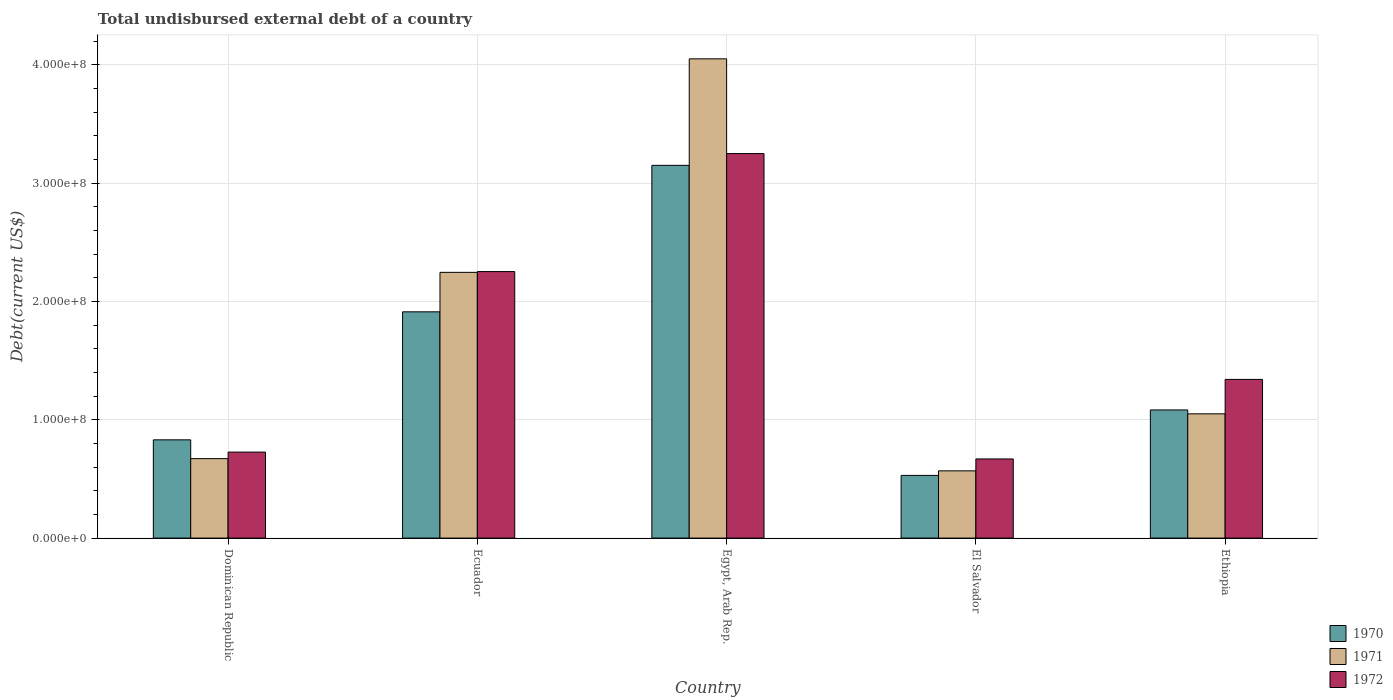How many groups of bars are there?
Give a very brief answer. 5. Are the number of bars per tick equal to the number of legend labels?
Provide a succinct answer. Yes. How many bars are there on the 4th tick from the right?
Keep it short and to the point. 3. What is the label of the 4th group of bars from the left?
Ensure brevity in your answer.  El Salvador. In how many cases, is the number of bars for a given country not equal to the number of legend labels?
Offer a terse response. 0. What is the total undisbursed external debt in 1971 in Ethiopia?
Your response must be concise. 1.05e+08. Across all countries, what is the maximum total undisbursed external debt in 1971?
Provide a short and direct response. 4.05e+08. Across all countries, what is the minimum total undisbursed external debt in 1972?
Your response must be concise. 6.69e+07. In which country was the total undisbursed external debt in 1971 maximum?
Provide a succinct answer. Egypt, Arab Rep. In which country was the total undisbursed external debt in 1972 minimum?
Your answer should be very brief. El Salvador. What is the total total undisbursed external debt in 1972 in the graph?
Ensure brevity in your answer.  8.24e+08. What is the difference between the total undisbursed external debt in 1971 in Dominican Republic and that in Ethiopia?
Your answer should be compact. -3.79e+07. What is the difference between the total undisbursed external debt in 1971 in Ecuador and the total undisbursed external debt in 1970 in Egypt, Arab Rep.?
Offer a very short reply. -9.04e+07. What is the average total undisbursed external debt in 1972 per country?
Your response must be concise. 1.65e+08. What is the difference between the total undisbursed external debt of/in 1970 and total undisbursed external debt of/in 1971 in Dominican Republic?
Provide a succinct answer. 1.59e+07. What is the ratio of the total undisbursed external debt in 1972 in Ecuador to that in Egypt, Arab Rep.?
Your answer should be compact. 0.69. Is the total undisbursed external debt in 1971 in Dominican Republic less than that in El Salvador?
Your answer should be very brief. No. What is the difference between the highest and the second highest total undisbursed external debt in 1971?
Keep it short and to the point. 3.00e+08. What is the difference between the highest and the lowest total undisbursed external debt in 1971?
Your response must be concise. 3.48e+08. Is the sum of the total undisbursed external debt in 1972 in El Salvador and Ethiopia greater than the maximum total undisbursed external debt in 1971 across all countries?
Provide a succinct answer. No. What does the 1st bar from the left in Ethiopia represents?
Offer a very short reply. 1970. Are the values on the major ticks of Y-axis written in scientific E-notation?
Offer a terse response. Yes. Does the graph contain any zero values?
Your response must be concise. No. How many legend labels are there?
Give a very brief answer. 3. How are the legend labels stacked?
Your response must be concise. Vertical. What is the title of the graph?
Your answer should be compact. Total undisbursed external debt of a country. What is the label or title of the X-axis?
Give a very brief answer. Country. What is the label or title of the Y-axis?
Keep it short and to the point. Debt(current US$). What is the Debt(current US$) in 1970 in Dominican Republic?
Your response must be concise. 8.30e+07. What is the Debt(current US$) of 1971 in Dominican Republic?
Keep it short and to the point. 6.71e+07. What is the Debt(current US$) of 1972 in Dominican Republic?
Your response must be concise. 7.27e+07. What is the Debt(current US$) of 1970 in Ecuador?
Give a very brief answer. 1.91e+08. What is the Debt(current US$) of 1971 in Ecuador?
Provide a short and direct response. 2.25e+08. What is the Debt(current US$) in 1972 in Ecuador?
Your response must be concise. 2.25e+08. What is the Debt(current US$) of 1970 in Egypt, Arab Rep.?
Give a very brief answer. 3.15e+08. What is the Debt(current US$) of 1971 in Egypt, Arab Rep.?
Your answer should be compact. 4.05e+08. What is the Debt(current US$) of 1972 in Egypt, Arab Rep.?
Give a very brief answer. 3.25e+08. What is the Debt(current US$) of 1970 in El Salvador?
Make the answer very short. 5.30e+07. What is the Debt(current US$) in 1971 in El Salvador?
Offer a terse response. 5.68e+07. What is the Debt(current US$) in 1972 in El Salvador?
Your response must be concise. 6.69e+07. What is the Debt(current US$) in 1970 in Ethiopia?
Offer a terse response. 1.08e+08. What is the Debt(current US$) of 1971 in Ethiopia?
Give a very brief answer. 1.05e+08. What is the Debt(current US$) in 1972 in Ethiopia?
Your response must be concise. 1.34e+08. Across all countries, what is the maximum Debt(current US$) in 1970?
Offer a very short reply. 3.15e+08. Across all countries, what is the maximum Debt(current US$) of 1971?
Your response must be concise. 4.05e+08. Across all countries, what is the maximum Debt(current US$) in 1972?
Your answer should be compact. 3.25e+08. Across all countries, what is the minimum Debt(current US$) in 1970?
Your answer should be very brief. 5.30e+07. Across all countries, what is the minimum Debt(current US$) of 1971?
Your answer should be very brief. 5.68e+07. Across all countries, what is the minimum Debt(current US$) in 1972?
Make the answer very short. 6.69e+07. What is the total Debt(current US$) of 1970 in the graph?
Your response must be concise. 7.50e+08. What is the total Debt(current US$) in 1971 in the graph?
Your answer should be very brief. 8.58e+08. What is the total Debt(current US$) in 1972 in the graph?
Your answer should be compact. 8.24e+08. What is the difference between the Debt(current US$) of 1970 in Dominican Republic and that in Ecuador?
Your answer should be very brief. -1.08e+08. What is the difference between the Debt(current US$) in 1971 in Dominican Republic and that in Ecuador?
Ensure brevity in your answer.  -1.57e+08. What is the difference between the Debt(current US$) of 1972 in Dominican Republic and that in Ecuador?
Your answer should be compact. -1.53e+08. What is the difference between the Debt(current US$) of 1970 in Dominican Republic and that in Egypt, Arab Rep.?
Give a very brief answer. -2.32e+08. What is the difference between the Debt(current US$) of 1971 in Dominican Republic and that in Egypt, Arab Rep.?
Offer a very short reply. -3.38e+08. What is the difference between the Debt(current US$) of 1972 in Dominican Republic and that in Egypt, Arab Rep.?
Provide a short and direct response. -2.52e+08. What is the difference between the Debt(current US$) in 1970 in Dominican Republic and that in El Salvador?
Keep it short and to the point. 3.01e+07. What is the difference between the Debt(current US$) of 1971 in Dominican Republic and that in El Salvador?
Your answer should be very brief. 1.03e+07. What is the difference between the Debt(current US$) in 1972 in Dominican Republic and that in El Salvador?
Ensure brevity in your answer.  5.80e+06. What is the difference between the Debt(current US$) in 1970 in Dominican Republic and that in Ethiopia?
Your response must be concise. -2.53e+07. What is the difference between the Debt(current US$) of 1971 in Dominican Republic and that in Ethiopia?
Offer a terse response. -3.79e+07. What is the difference between the Debt(current US$) of 1972 in Dominican Republic and that in Ethiopia?
Make the answer very short. -6.14e+07. What is the difference between the Debt(current US$) of 1970 in Ecuador and that in Egypt, Arab Rep.?
Keep it short and to the point. -1.24e+08. What is the difference between the Debt(current US$) in 1971 in Ecuador and that in Egypt, Arab Rep.?
Give a very brief answer. -1.80e+08. What is the difference between the Debt(current US$) in 1972 in Ecuador and that in Egypt, Arab Rep.?
Your response must be concise. -9.97e+07. What is the difference between the Debt(current US$) of 1970 in Ecuador and that in El Salvador?
Your answer should be very brief. 1.38e+08. What is the difference between the Debt(current US$) in 1971 in Ecuador and that in El Salvador?
Keep it short and to the point. 1.68e+08. What is the difference between the Debt(current US$) of 1972 in Ecuador and that in El Salvador?
Your answer should be compact. 1.58e+08. What is the difference between the Debt(current US$) in 1970 in Ecuador and that in Ethiopia?
Provide a short and direct response. 8.29e+07. What is the difference between the Debt(current US$) in 1971 in Ecuador and that in Ethiopia?
Provide a short and direct response. 1.20e+08. What is the difference between the Debt(current US$) of 1972 in Ecuador and that in Ethiopia?
Provide a short and direct response. 9.11e+07. What is the difference between the Debt(current US$) in 1970 in Egypt, Arab Rep. and that in El Salvador?
Offer a terse response. 2.62e+08. What is the difference between the Debt(current US$) in 1971 in Egypt, Arab Rep. and that in El Salvador?
Provide a succinct answer. 3.48e+08. What is the difference between the Debt(current US$) of 1972 in Egypt, Arab Rep. and that in El Salvador?
Give a very brief answer. 2.58e+08. What is the difference between the Debt(current US$) in 1970 in Egypt, Arab Rep. and that in Ethiopia?
Provide a short and direct response. 2.07e+08. What is the difference between the Debt(current US$) in 1971 in Egypt, Arab Rep. and that in Ethiopia?
Offer a very short reply. 3.00e+08. What is the difference between the Debt(current US$) in 1972 in Egypt, Arab Rep. and that in Ethiopia?
Offer a very short reply. 1.91e+08. What is the difference between the Debt(current US$) of 1970 in El Salvador and that in Ethiopia?
Offer a terse response. -5.53e+07. What is the difference between the Debt(current US$) of 1971 in El Salvador and that in Ethiopia?
Ensure brevity in your answer.  -4.82e+07. What is the difference between the Debt(current US$) in 1972 in El Salvador and that in Ethiopia?
Your answer should be very brief. -6.72e+07. What is the difference between the Debt(current US$) of 1970 in Dominican Republic and the Debt(current US$) of 1971 in Ecuador?
Make the answer very short. -1.42e+08. What is the difference between the Debt(current US$) in 1970 in Dominican Republic and the Debt(current US$) in 1972 in Ecuador?
Offer a very short reply. -1.42e+08. What is the difference between the Debt(current US$) in 1971 in Dominican Republic and the Debt(current US$) in 1972 in Ecuador?
Offer a very short reply. -1.58e+08. What is the difference between the Debt(current US$) of 1970 in Dominican Republic and the Debt(current US$) of 1971 in Egypt, Arab Rep.?
Offer a terse response. -3.22e+08. What is the difference between the Debt(current US$) in 1970 in Dominican Republic and the Debt(current US$) in 1972 in Egypt, Arab Rep.?
Your answer should be compact. -2.42e+08. What is the difference between the Debt(current US$) in 1971 in Dominican Republic and the Debt(current US$) in 1972 in Egypt, Arab Rep.?
Give a very brief answer. -2.58e+08. What is the difference between the Debt(current US$) in 1970 in Dominican Republic and the Debt(current US$) in 1971 in El Salvador?
Your answer should be very brief. 2.62e+07. What is the difference between the Debt(current US$) of 1970 in Dominican Republic and the Debt(current US$) of 1972 in El Salvador?
Keep it short and to the point. 1.61e+07. What is the difference between the Debt(current US$) in 1971 in Dominican Republic and the Debt(current US$) in 1972 in El Salvador?
Provide a short and direct response. 2.60e+05. What is the difference between the Debt(current US$) of 1970 in Dominican Republic and the Debt(current US$) of 1971 in Ethiopia?
Your response must be concise. -2.20e+07. What is the difference between the Debt(current US$) in 1970 in Dominican Republic and the Debt(current US$) in 1972 in Ethiopia?
Give a very brief answer. -5.11e+07. What is the difference between the Debt(current US$) of 1971 in Dominican Republic and the Debt(current US$) of 1972 in Ethiopia?
Provide a short and direct response. -6.69e+07. What is the difference between the Debt(current US$) of 1970 in Ecuador and the Debt(current US$) of 1971 in Egypt, Arab Rep.?
Offer a very short reply. -2.14e+08. What is the difference between the Debt(current US$) in 1970 in Ecuador and the Debt(current US$) in 1972 in Egypt, Arab Rep.?
Ensure brevity in your answer.  -1.34e+08. What is the difference between the Debt(current US$) in 1971 in Ecuador and the Debt(current US$) in 1972 in Egypt, Arab Rep.?
Your answer should be compact. -1.00e+08. What is the difference between the Debt(current US$) of 1970 in Ecuador and the Debt(current US$) of 1971 in El Salvador?
Provide a short and direct response. 1.34e+08. What is the difference between the Debt(current US$) of 1970 in Ecuador and the Debt(current US$) of 1972 in El Salvador?
Offer a very short reply. 1.24e+08. What is the difference between the Debt(current US$) of 1971 in Ecuador and the Debt(current US$) of 1972 in El Salvador?
Provide a succinct answer. 1.58e+08. What is the difference between the Debt(current US$) of 1970 in Ecuador and the Debt(current US$) of 1971 in Ethiopia?
Offer a very short reply. 8.62e+07. What is the difference between the Debt(current US$) of 1970 in Ecuador and the Debt(current US$) of 1972 in Ethiopia?
Make the answer very short. 5.71e+07. What is the difference between the Debt(current US$) of 1971 in Ecuador and the Debt(current US$) of 1972 in Ethiopia?
Ensure brevity in your answer.  9.05e+07. What is the difference between the Debt(current US$) of 1970 in Egypt, Arab Rep. and the Debt(current US$) of 1971 in El Salvador?
Offer a very short reply. 2.58e+08. What is the difference between the Debt(current US$) in 1970 in Egypt, Arab Rep. and the Debt(current US$) in 1972 in El Salvador?
Give a very brief answer. 2.48e+08. What is the difference between the Debt(current US$) in 1971 in Egypt, Arab Rep. and the Debt(current US$) in 1972 in El Salvador?
Provide a succinct answer. 3.38e+08. What is the difference between the Debt(current US$) of 1970 in Egypt, Arab Rep. and the Debt(current US$) of 1971 in Ethiopia?
Offer a very short reply. 2.10e+08. What is the difference between the Debt(current US$) of 1970 in Egypt, Arab Rep. and the Debt(current US$) of 1972 in Ethiopia?
Give a very brief answer. 1.81e+08. What is the difference between the Debt(current US$) in 1971 in Egypt, Arab Rep. and the Debt(current US$) in 1972 in Ethiopia?
Offer a terse response. 2.71e+08. What is the difference between the Debt(current US$) in 1970 in El Salvador and the Debt(current US$) in 1971 in Ethiopia?
Provide a short and direct response. -5.20e+07. What is the difference between the Debt(current US$) of 1970 in El Salvador and the Debt(current US$) of 1972 in Ethiopia?
Provide a short and direct response. -8.11e+07. What is the difference between the Debt(current US$) of 1971 in El Salvador and the Debt(current US$) of 1972 in Ethiopia?
Your response must be concise. -7.73e+07. What is the average Debt(current US$) of 1970 per country?
Make the answer very short. 1.50e+08. What is the average Debt(current US$) of 1971 per country?
Your answer should be very brief. 1.72e+08. What is the average Debt(current US$) in 1972 per country?
Your answer should be very brief. 1.65e+08. What is the difference between the Debt(current US$) of 1970 and Debt(current US$) of 1971 in Dominican Republic?
Your response must be concise. 1.59e+07. What is the difference between the Debt(current US$) in 1970 and Debt(current US$) in 1972 in Dominican Republic?
Give a very brief answer. 1.04e+07. What is the difference between the Debt(current US$) of 1971 and Debt(current US$) of 1972 in Dominican Republic?
Ensure brevity in your answer.  -5.54e+06. What is the difference between the Debt(current US$) in 1970 and Debt(current US$) in 1971 in Ecuador?
Provide a short and direct response. -3.34e+07. What is the difference between the Debt(current US$) in 1970 and Debt(current US$) in 1972 in Ecuador?
Your answer should be compact. -3.40e+07. What is the difference between the Debt(current US$) in 1971 and Debt(current US$) in 1972 in Ecuador?
Your answer should be very brief. -6.61e+05. What is the difference between the Debt(current US$) of 1970 and Debt(current US$) of 1971 in Egypt, Arab Rep.?
Your answer should be compact. -9.00e+07. What is the difference between the Debt(current US$) in 1970 and Debt(current US$) in 1972 in Egypt, Arab Rep.?
Keep it short and to the point. -9.93e+06. What is the difference between the Debt(current US$) of 1971 and Debt(current US$) of 1972 in Egypt, Arab Rep.?
Keep it short and to the point. 8.01e+07. What is the difference between the Debt(current US$) of 1970 and Debt(current US$) of 1971 in El Salvador?
Your answer should be very brief. -3.85e+06. What is the difference between the Debt(current US$) in 1970 and Debt(current US$) in 1972 in El Salvador?
Offer a very short reply. -1.39e+07. What is the difference between the Debt(current US$) of 1971 and Debt(current US$) of 1972 in El Salvador?
Give a very brief answer. -1.01e+07. What is the difference between the Debt(current US$) in 1970 and Debt(current US$) in 1971 in Ethiopia?
Give a very brief answer. 3.29e+06. What is the difference between the Debt(current US$) in 1970 and Debt(current US$) in 1972 in Ethiopia?
Offer a very short reply. -2.58e+07. What is the difference between the Debt(current US$) in 1971 and Debt(current US$) in 1972 in Ethiopia?
Provide a short and direct response. -2.91e+07. What is the ratio of the Debt(current US$) of 1970 in Dominican Republic to that in Ecuador?
Offer a terse response. 0.43. What is the ratio of the Debt(current US$) of 1971 in Dominican Republic to that in Ecuador?
Keep it short and to the point. 0.3. What is the ratio of the Debt(current US$) of 1972 in Dominican Republic to that in Ecuador?
Provide a short and direct response. 0.32. What is the ratio of the Debt(current US$) of 1970 in Dominican Republic to that in Egypt, Arab Rep.?
Offer a terse response. 0.26. What is the ratio of the Debt(current US$) of 1971 in Dominican Republic to that in Egypt, Arab Rep.?
Offer a very short reply. 0.17. What is the ratio of the Debt(current US$) of 1972 in Dominican Republic to that in Egypt, Arab Rep.?
Provide a succinct answer. 0.22. What is the ratio of the Debt(current US$) of 1970 in Dominican Republic to that in El Salvador?
Offer a very short reply. 1.57. What is the ratio of the Debt(current US$) of 1971 in Dominican Republic to that in El Salvador?
Ensure brevity in your answer.  1.18. What is the ratio of the Debt(current US$) of 1972 in Dominican Republic to that in El Salvador?
Offer a terse response. 1.09. What is the ratio of the Debt(current US$) of 1970 in Dominican Republic to that in Ethiopia?
Provide a succinct answer. 0.77. What is the ratio of the Debt(current US$) of 1971 in Dominican Republic to that in Ethiopia?
Make the answer very short. 0.64. What is the ratio of the Debt(current US$) of 1972 in Dominican Republic to that in Ethiopia?
Your answer should be very brief. 0.54. What is the ratio of the Debt(current US$) in 1970 in Ecuador to that in Egypt, Arab Rep.?
Your answer should be very brief. 0.61. What is the ratio of the Debt(current US$) in 1971 in Ecuador to that in Egypt, Arab Rep.?
Provide a short and direct response. 0.55. What is the ratio of the Debt(current US$) of 1972 in Ecuador to that in Egypt, Arab Rep.?
Make the answer very short. 0.69. What is the ratio of the Debt(current US$) of 1970 in Ecuador to that in El Salvador?
Offer a very short reply. 3.61. What is the ratio of the Debt(current US$) in 1971 in Ecuador to that in El Salvador?
Ensure brevity in your answer.  3.95. What is the ratio of the Debt(current US$) of 1972 in Ecuador to that in El Salvador?
Keep it short and to the point. 3.37. What is the ratio of the Debt(current US$) in 1970 in Ecuador to that in Ethiopia?
Keep it short and to the point. 1.77. What is the ratio of the Debt(current US$) in 1971 in Ecuador to that in Ethiopia?
Your answer should be very brief. 2.14. What is the ratio of the Debt(current US$) in 1972 in Ecuador to that in Ethiopia?
Give a very brief answer. 1.68. What is the ratio of the Debt(current US$) of 1970 in Egypt, Arab Rep. to that in El Salvador?
Your answer should be compact. 5.95. What is the ratio of the Debt(current US$) of 1971 in Egypt, Arab Rep. to that in El Salvador?
Offer a very short reply. 7.13. What is the ratio of the Debt(current US$) in 1972 in Egypt, Arab Rep. to that in El Salvador?
Give a very brief answer. 4.86. What is the ratio of the Debt(current US$) in 1970 in Egypt, Arab Rep. to that in Ethiopia?
Keep it short and to the point. 2.91. What is the ratio of the Debt(current US$) in 1971 in Egypt, Arab Rep. to that in Ethiopia?
Make the answer very short. 3.86. What is the ratio of the Debt(current US$) in 1972 in Egypt, Arab Rep. to that in Ethiopia?
Your response must be concise. 2.42. What is the ratio of the Debt(current US$) of 1970 in El Salvador to that in Ethiopia?
Ensure brevity in your answer.  0.49. What is the ratio of the Debt(current US$) of 1971 in El Salvador to that in Ethiopia?
Provide a succinct answer. 0.54. What is the ratio of the Debt(current US$) in 1972 in El Salvador to that in Ethiopia?
Provide a succinct answer. 0.5. What is the difference between the highest and the second highest Debt(current US$) of 1970?
Ensure brevity in your answer.  1.24e+08. What is the difference between the highest and the second highest Debt(current US$) in 1971?
Ensure brevity in your answer.  1.80e+08. What is the difference between the highest and the second highest Debt(current US$) of 1972?
Offer a terse response. 9.97e+07. What is the difference between the highest and the lowest Debt(current US$) in 1970?
Provide a succinct answer. 2.62e+08. What is the difference between the highest and the lowest Debt(current US$) in 1971?
Make the answer very short. 3.48e+08. What is the difference between the highest and the lowest Debt(current US$) in 1972?
Your answer should be compact. 2.58e+08. 